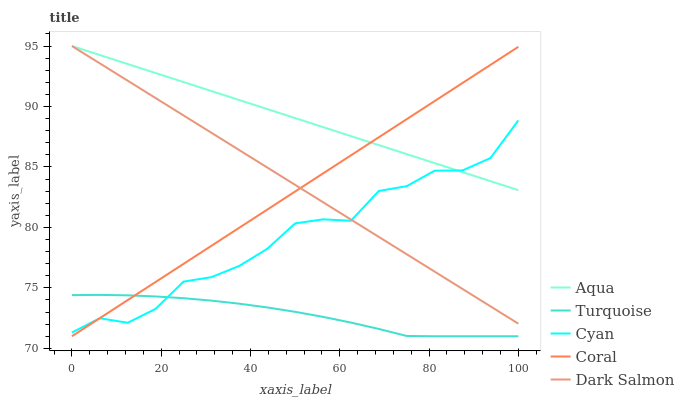Does Turquoise have the minimum area under the curve?
Answer yes or no. Yes. Does Aqua have the maximum area under the curve?
Answer yes or no. Yes. Does Aqua have the minimum area under the curve?
Answer yes or no. No. Does Turquoise have the maximum area under the curve?
Answer yes or no. No. Is Aqua the smoothest?
Answer yes or no. Yes. Is Cyan the roughest?
Answer yes or no. Yes. Is Turquoise the smoothest?
Answer yes or no. No. Is Turquoise the roughest?
Answer yes or no. No. Does Turquoise have the lowest value?
Answer yes or no. Yes. Does Aqua have the lowest value?
Answer yes or no. No. Does Dark Salmon have the highest value?
Answer yes or no. Yes. Does Turquoise have the highest value?
Answer yes or no. No. Is Turquoise less than Dark Salmon?
Answer yes or no. Yes. Is Aqua greater than Turquoise?
Answer yes or no. Yes. Does Aqua intersect Coral?
Answer yes or no. Yes. Is Aqua less than Coral?
Answer yes or no. No. Is Aqua greater than Coral?
Answer yes or no. No. Does Turquoise intersect Dark Salmon?
Answer yes or no. No. 